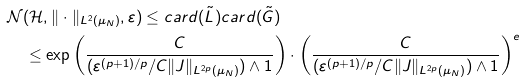Convert formula to latex. <formula><loc_0><loc_0><loc_500><loc_500>& \mathcal { N } ( \mathcal { H } , \| \cdot \| _ { L ^ { 2 } ( \mu _ { N } ) } , \varepsilon ) \leq c a r d ( \tilde { L } ) c a r d ( \tilde { G } ) \\ & \quad \leq \exp \left ( \frac { C } { ( \varepsilon ^ { ( p + 1 ) / p } / C \| J \| _ { L ^ { 2 p } ( \mu _ { N } ) } ) \wedge 1 } \right ) \cdot \left ( \frac { C } { ( \varepsilon ^ { ( p + 1 ) / p } / C \| J \| _ { L ^ { 2 p } ( \mu _ { N } ) } ) \wedge 1 } \right ) ^ { e }</formula> 